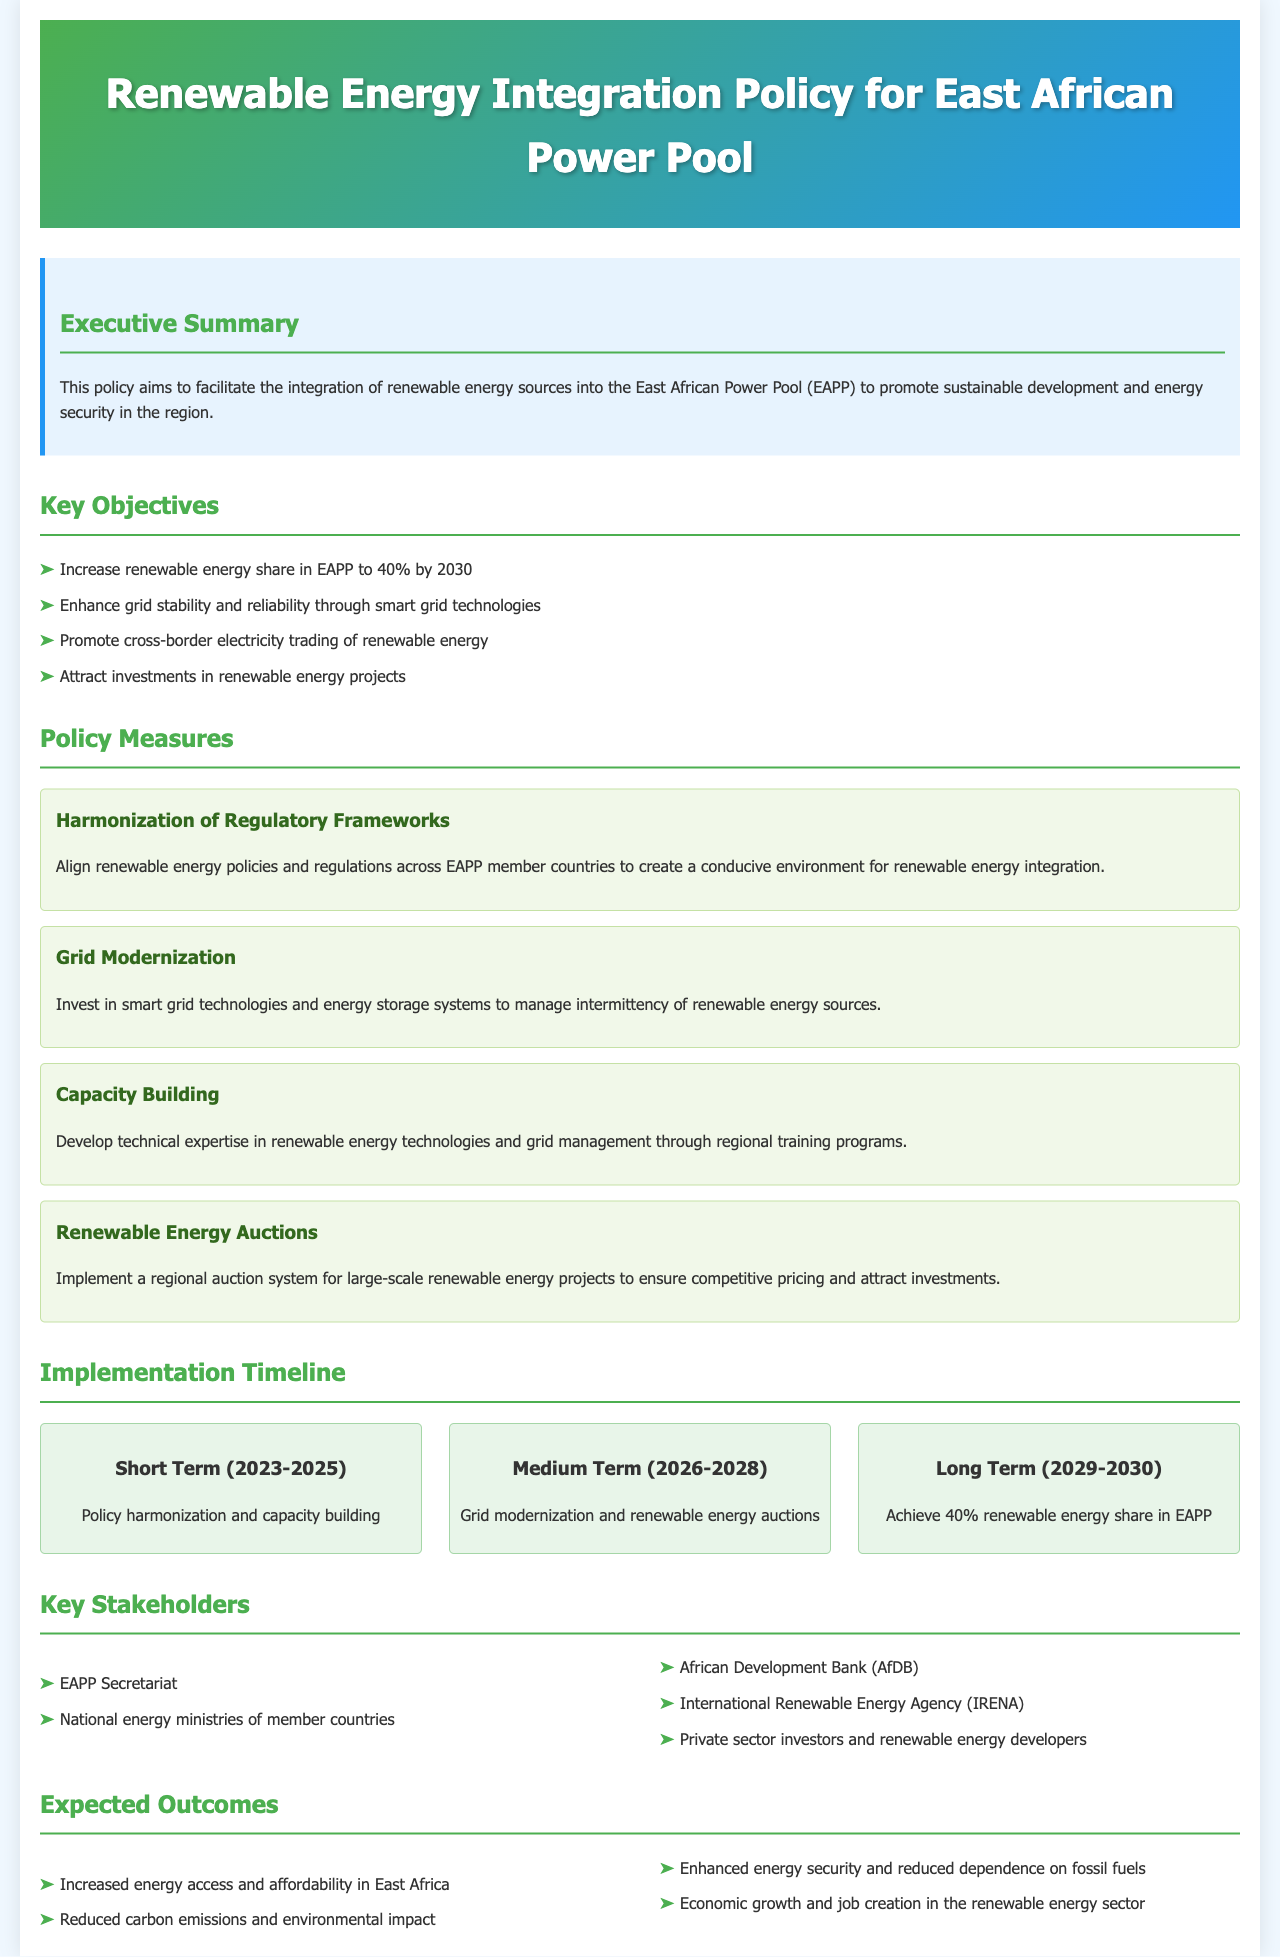What is the renewable energy share target for EAPP by 2030? The document states the target is to increase the renewable energy share in EAPP to 40% by 2030.
Answer: 40% What is one of the key measures for enhancing grid stability? The document mentions investing in smart grid technologies as a measure to enhance grid stability and reliability.
Answer: Smart grid technologies Who is one of the key stakeholders mentioned in the document? The document lists several stakeholders, including the African Development Bank (AfDB), who plays a significant role in renewable energy projects.
Answer: African Development Bank (AfDB) What is the short-term goal for the implementation timeline? According to the document, the short-term goal (2023-2025) involves policy harmonization and capacity building.
Answer: Policy harmonization and capacity building What is the main purpose of the policy? The executive summary states that the main purpose is to facilitate the integration of renewable energy sources into the East African Power Pool for sustainable development and energy security.
Answer: Facilitate the integration of renewable energy What outcome relates to carbon emissions? The document indicates one of the expected outcomes is reduced carbon emissions and environmental impact.
Answer: Reduced carbon emissions What policy measure is aimed at attracting investments? The document discusses implementing a regional auction system for large-scale renewable energy projects to ensure competitive pricing and attract investments.
Answer: Renewable Energy Auctions What is the medium-term focus (2026-2028) of the implementation timeline? The document expresses that the medium-term focus includes grid modernization and renewable energy auctions.
Answer: Grid modernization and renewable energy auctions 